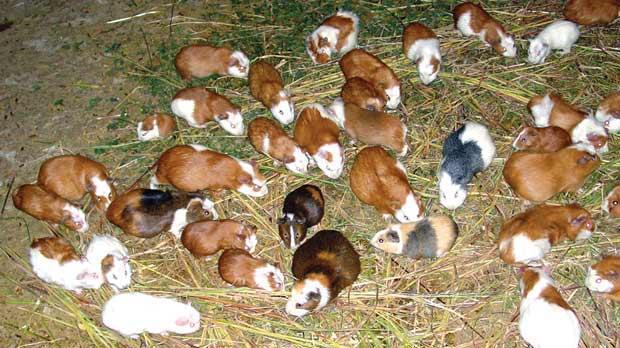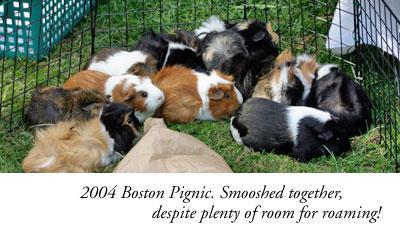The first image is the image on the left, the second image is the image on the right. Examine the images to the left and right. Is the description "Neither individual image includes more than seven guinea pigs." accurate? Answer yes or no. No. The first image is the image on the left, the second image is the image on the right. Assess this claim about the two images: "Several guinea pigs are eating hay.". Correct or not? Answer yes or no. Yes. 